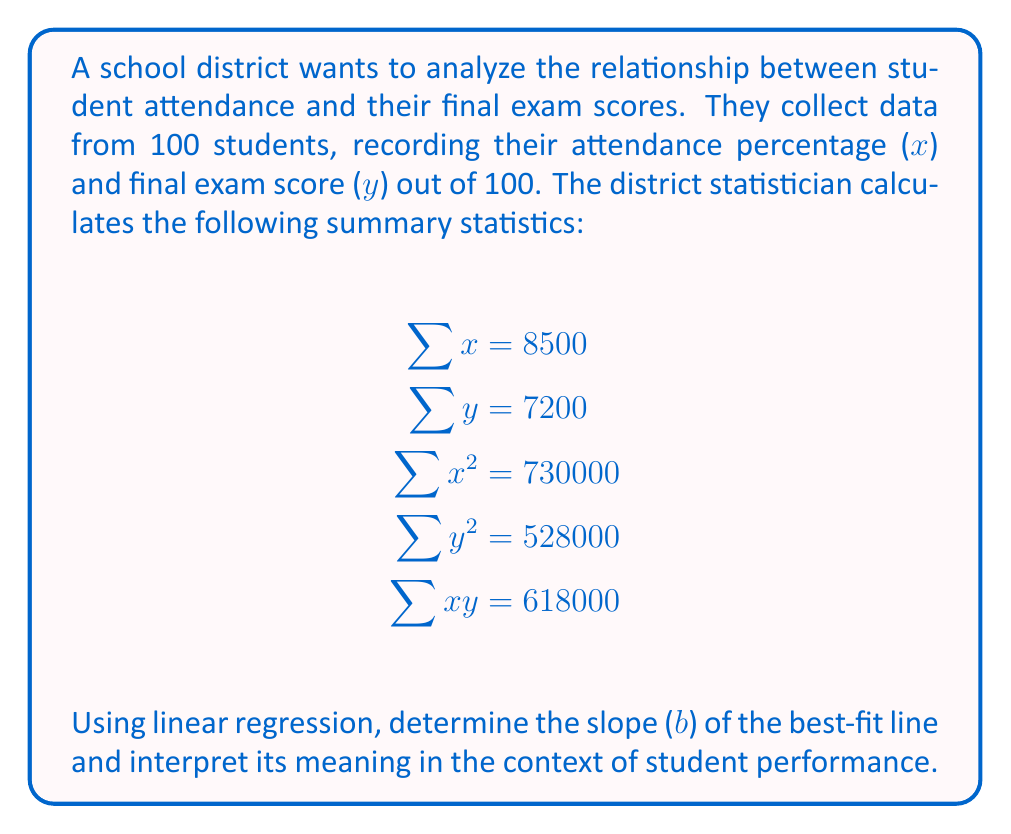Provide a solution to this math problem. To find the slope (b) of the best-fit line using linear regression, we'll use the following formula:

$$b = \frac{n\sum xy - \sum x \sum y}{n\sum x^2 - (\sum x)^2}$$

Where n is the number of data points (students in this case).

Step 1: Substitute the given values into the formula.
n = 100
$\sum x = 8500$
$\sum y = 7200$
$\sum x^2 = 730000$
$\sum xy = 618000$

$$b = \frac{100(618000) - (8500)(7200)}{100(730000) - (8500)^2}$$

Step 2: Simplify the numerator and denominator.
$$b = \frac{61800000 - 61200000}{73000000 - 72250000}$$

Step 3: Calculate the final value.
$$b = \frac{600000}{750000} = 0.8$$

Interpretation: The slope (b) of 0.8 indicates that, on average, for every 1 percentage point increase in attendance, a student's final exam score is expected to increase by 0.8 points. This positive relationship suggests that higher attendance is associated with better exam performance.

For education policy analysts, this information can be valuable in demonstrating the importance of attendance and potentially developing strategies to improve student attendance rates as a means of enhancing academic performance.
Answer: The slope (b) of the best-fit line is 0.8, indicating that for every 1 percentage point increase in attendance, a student's final exam score is expected to increase by 0.8 points on average. 